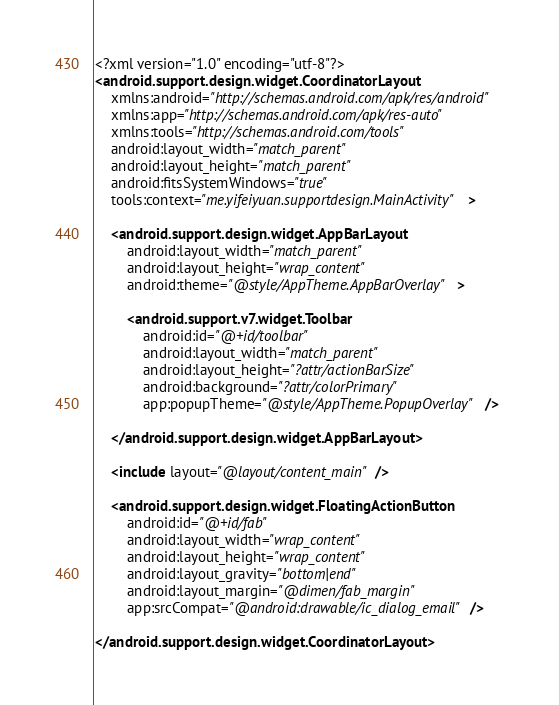<code> <loc_0><loc_0><loc_500><loc_500><_XML_><?xml version="1.0" encoding="utf-8"?>
<android.support.design.widget.CoordinatorLayout
    xmlns:android="http://schemas.android.com/apk/res/android"
    xmlns:app="http://schemas.android.com/apk/res-auto"
    xmlns:tools="http://schemas.android.com/tools"
    android:layout_width="match_parent"
    android:layout_height="match_parent"
    android:fitsSystemWindows="true"
    tools:context="me.yifeiyuan.supportdesign.MainActivity">

    <android.support.design.widget.AppBarLayout
        android:layout_width="match_parent"
        android:layout_height="wrap_content"
        android:theme="@style/AppTheme.AppBarOverlay">

        <android.support.v7.widget.Toolbar
            android:id="@+id/toolbar"
            android:layout_width="match_parent"
            android:layout_height="?attr/actionBarSize"
            android:background="?attr/colorPrimary"
            app:popupTheme="@style/AppTheme.PopupOverlay"/>

    </android.support.design.widget.AppBarLayout>

    <include layout="@layout/content_main"/>

    <android.support.design.widget.FloatingActionButton
        android:id="@+id/fab"
        android:layout_width="wrap_content"
        android:layout_height="wrap_content"
        android:layout_gravity="bottom|end"
        android:layout_margin="@dimen/fab_margin"
        app:srcCompat="@android:drawable/ic_dialog_email"/>

</android.support.design.widget.CoordinatorLayout>
</code> 